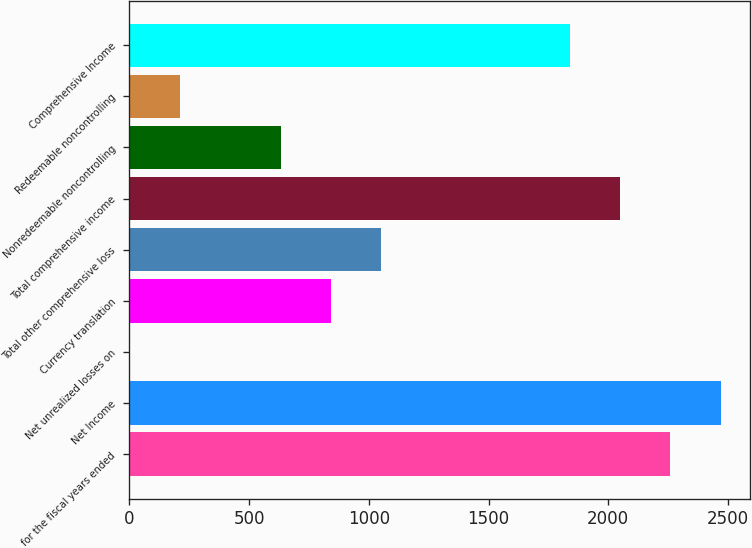Convert chart to OTSL. <chart><loc_0><loc_0><loc_500><loc_500><bar_chart><fcel>for the fiscal years ended<fcel>Net Income<fcel>Net unrealized losses on<fcel>Currency translation<fcel>Total other comprehensive loss<fcel>Total comprehensive income<fcel>Nonredeemable noncontrolling<fcel>Redeemable noncontrolling<fcel>Comprehensive Income<nl><fcel>2259.62<fcel>2470.03<fcel>0.6<fcel>842.24<fcel>1052.65<fcel>2049.21<fcel>631.83<fcel>211.01<fcel>1838.8<nl></chart> 